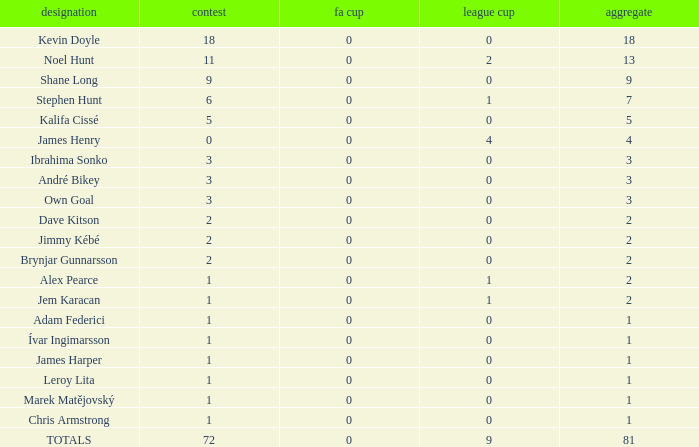What is the total championships that the league cup is less than 0? None. Write the full table. {'header': ['designation', 'contest', 'fa cup', 'league cup', 'aggregate'], 'rows': [['Kevin Doyle', '18', '0', '0', '18'], ['Noel Hunt', '11', '0', '2', '13'], ['Shane Long', '9', '0', '0', '9'], ['Stephen Hunt', '6', '0', '1', '7'], ['Kalifa Cissé', '5', '0', '0', '5'], ['James Henry', '0', '0', '4', '4'], ['Ibrahima Sonko', '3', '0', '0', '3'], ['André Bikey', '3', '0', '0', '3'], ['Own Goal', '3', '0', '0', '3'], ['Dave Kitson', '2', '0', '0', '2'], ['Jimmy Kébé', '2', '0', '0', '2'], ['Brynjar Gunnarsson', '2', '0', '0', '2'], ['Alex Pearce', '1', '0', '1', '2'], ['Jem Karacan', '1', '0', '1', '2'], ['Adam Federici', '1', '0', '0', '1'], ['Ívar Ingimarsson', '1', '0', '0', '1'], ['James Harper', '1', '0', '0', '1'], ['Leroy Lita', '1', '0', '0', '1'], ['Marek Matějovský', '1', '0', '0', '1'], ['Chris Armstrong', '1', '0', '0', '1'], ['TOTALS', '72', '0', '9', '81']]} 